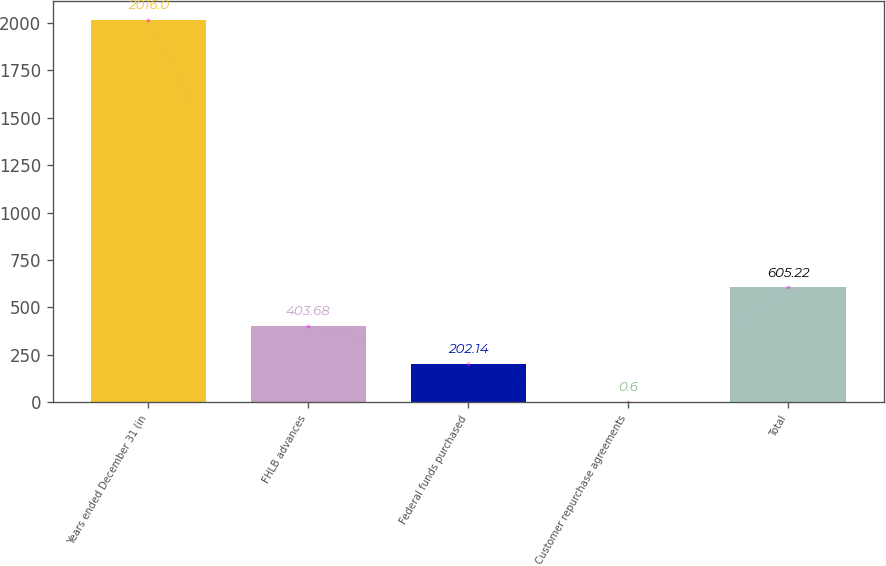Convert chart. <chart><loc_0><loc_0><loc_500><loc_500><bar_chart><fcel>Years ended December 31 (in<fcel>FHLB advances<fcel>Federal funds purchased<fcel>Customer repurchase agreements<fcel>Total<nl><fcel>2016<fcel>403.68<fcel>202.14<fcel>0.6<fcel>605.22<nl></chart> 